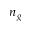Convert formula to latex. <formula><loc_0><loc_0><loc_500><loc_500>n _ { g }</formula> 